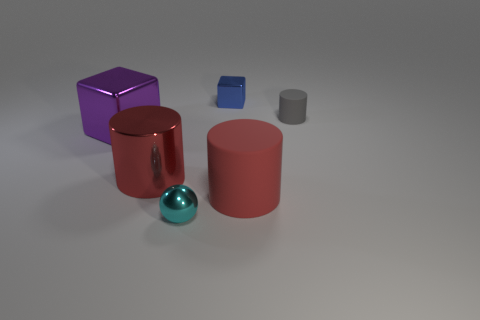Does the rubber cylinder left of the small gray cylinder have the same color as the metallic cylinder?
Provide a succinct answer. Yes. What material is the small gray object that is the same shape as the red metal object?
Provide a succinct answer. Rubber. The tiny object in front of the cylinder to the left of the matte object left of the small rubber cylinder is what shape?
Your answer should be very brief. Sphere. Is the number of tiny blue things that are in front of the purple cube greater than the number of big metal objects?
Your answer should be compact. No. Do the red object that is right of the tiny blue cube and the small cyan metal object have the same shape?
Your answer should be very brief. No. What material is the cylinder behind the purple block?
Make the answer very short. Rubber. How many big red shiny objects have the same shape as the red rubber object?
Offer a terse response. 1. What is the big cylinder to the right of the small shiny object that is behind the purple shiny cube made of?
Your answer should be very brief. Rubber. What shape is the matte object that is the same color as the metallic cylinder?
Your answer should be very brief. Cylinder. Are there any red cylinders made of the same material as the purple thing?
Your answer should be compact. Yes. 